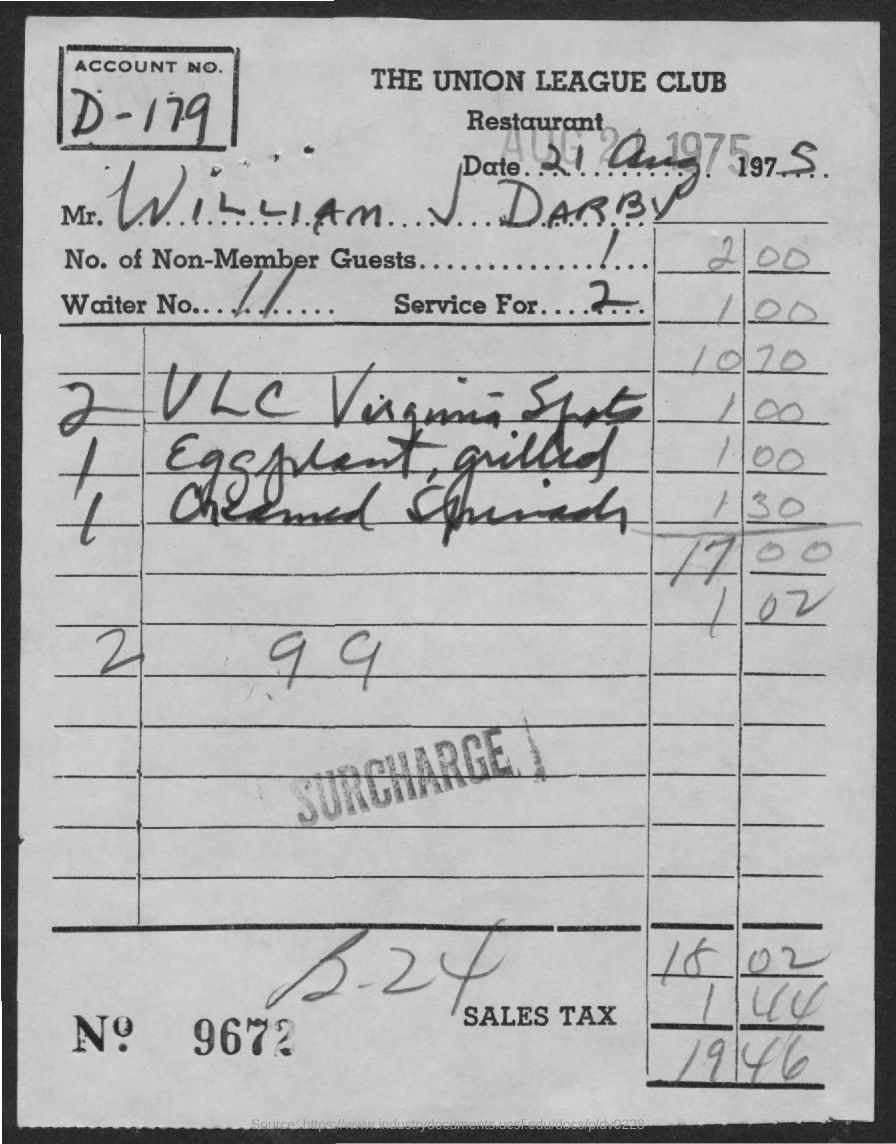Indicate a few pertinent items in this graphic. The name of the restaurant is The Union League Club. The service is for 2.. The customer's name listed on the bill is William J Darby. There are 1 to 1000 non-member guests. The sales tax charged is 1.44%. 